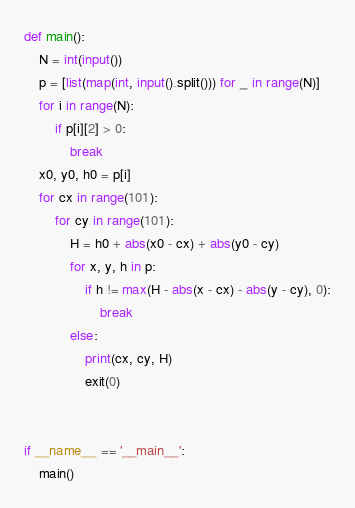<code> <loc_0><loc_0><loc_500><loc_500><_Python_>def main():
    N = int(input())
    p = [list(map(int, input().split())) for _ in range(N)]
    for i in range(N):
        if p[i][2] > 0:
            break
    x0, y0, h0 = p[i]
    for cx in range(101):
        for cy in range(101):
            H = h0 + abs(x0 - cx) + abs(y0 - cy)
            for x, y, h in p:
                if h != max(H - abs(x - cx) - abs(y - cy), 0):
                    break
            else:
                print(cx, cy, H)
                exit(0)


if __name__ == '__main__':
    main()</code> 